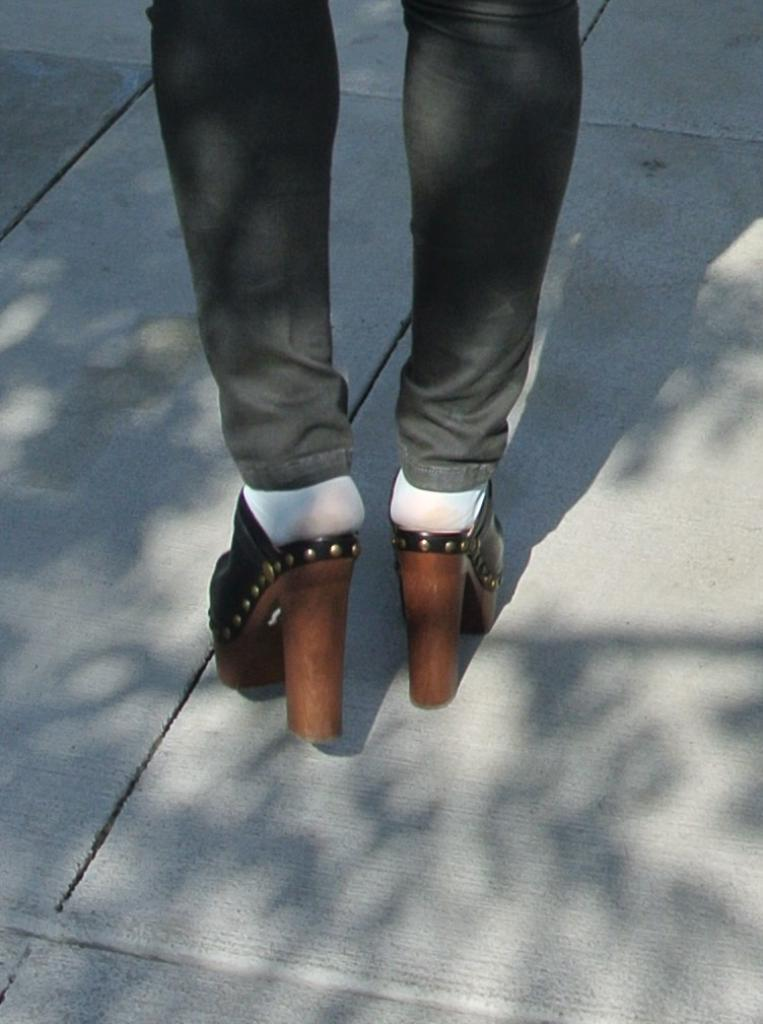What body part of a person is visible in the image? There are a person's legs visible in the image. What type of footwear is the person wearing? The person is wearing high heels. What type of vest is the person wearing in the image? There is no vest visible in the image; only the person's legs and high heels can be seen. 